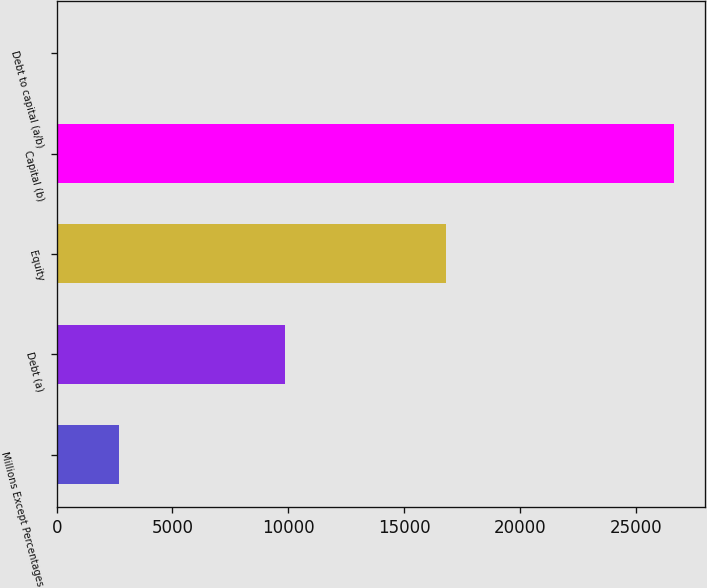<chart> <loc_0><loc_0><loc_500><loc_500><bar_chart><fcel>Millions Except Percentages<fcel>Debt (a)<fcel>Equity<fcel>Capital (b)<fcel>Debt to capital (a/b)<nl><fcel>2698.2<fcel>9848<fcel>16801<fcel>26649<fcel>37<nl></chart> 